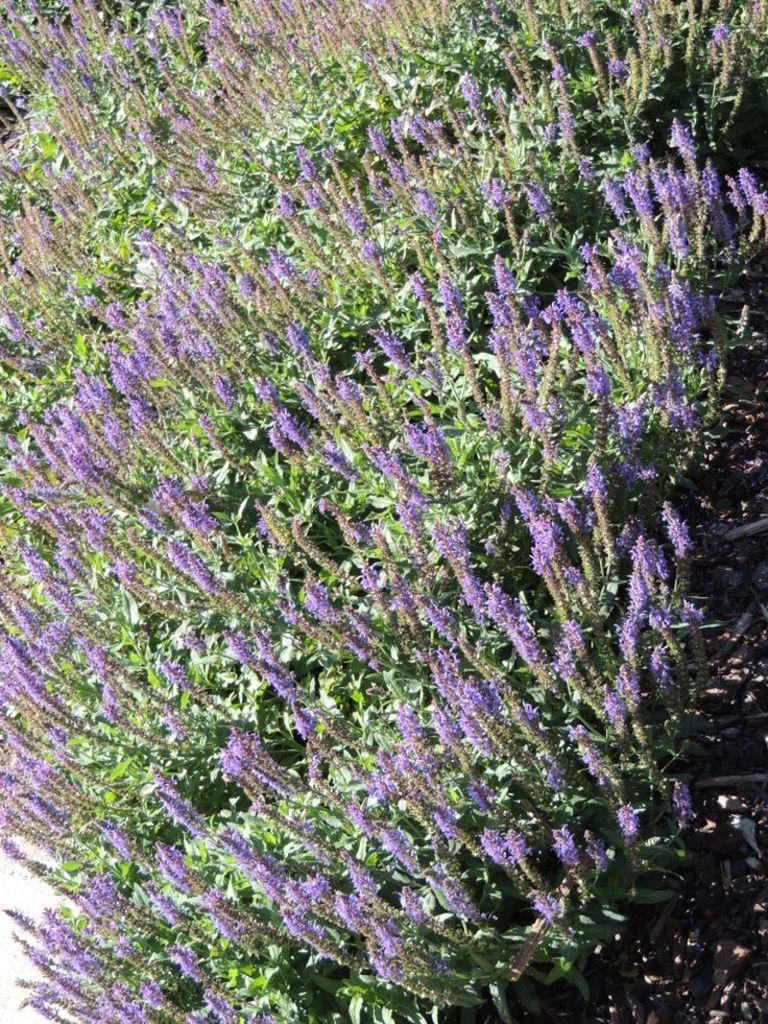What type of landscape is depicted in the image? There are flower fields in the image. Can you describe the vegetation in the image? The image features fields of flowers. What might the colors of the flowers be? The colors of the flowers in the fields may vary, but they are likely to be bright and vibrant. Where is the waste disposal unit located in the image? There is no waste disposal unit present in the image, as it features flower fields. What type of pot can be seen in the image? There is no pot present in the image; it features flower fields. 